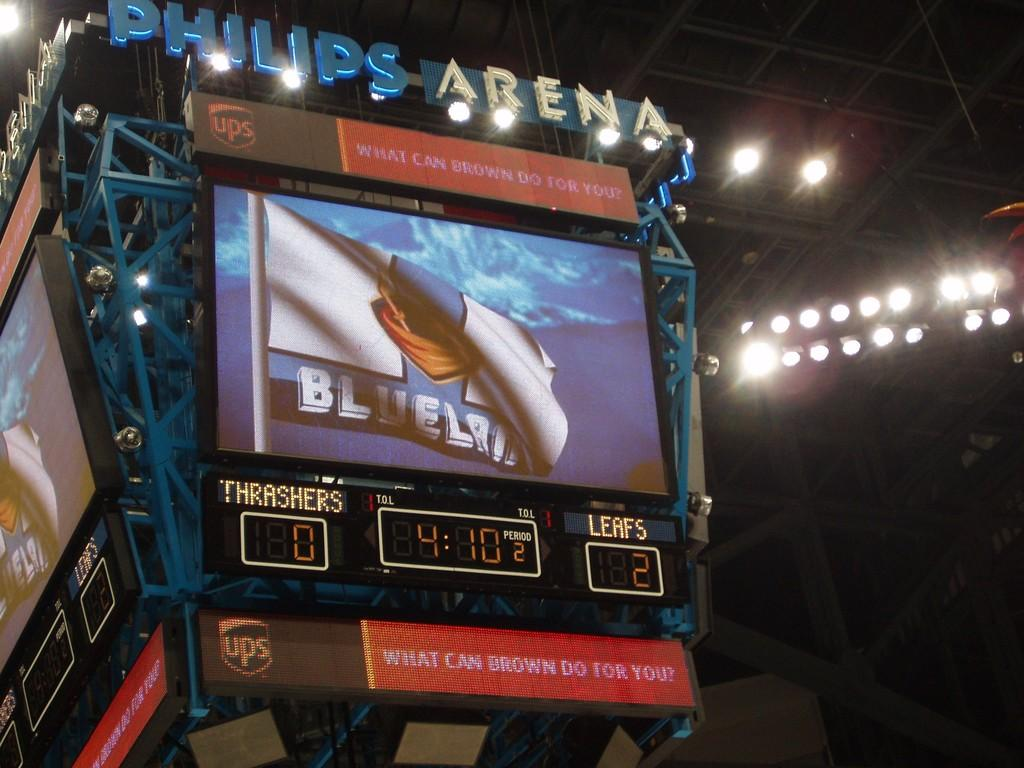<image>
Render a clear and concise summary of the photo. a Philips Arena sports display featuring a game between the Thrashers and Leafs. 